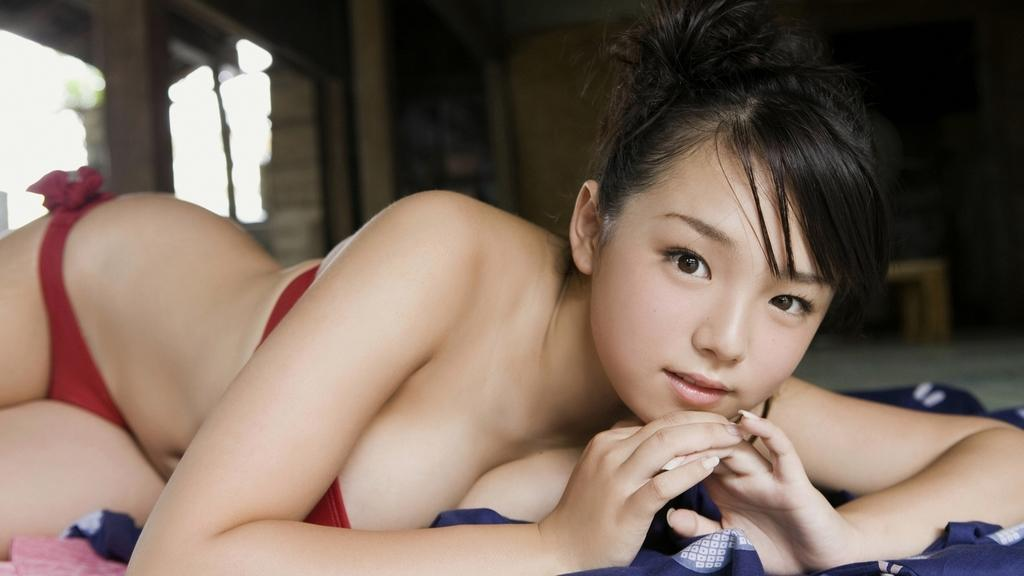What is the main subject in the center of the image? There is a woman lying in the center of the image. What is the woman lying on? There is a bed at the bottom of the image. What can be seen in the background of the image? There is a wall and pillars in the background of the image. Are there any other objects visible in the background? Yes, there are other objects visible in the background of the image. What type of drink is the woman holding in the image? There is no drink visible in the image; the woman is lying down and not holding anything. 